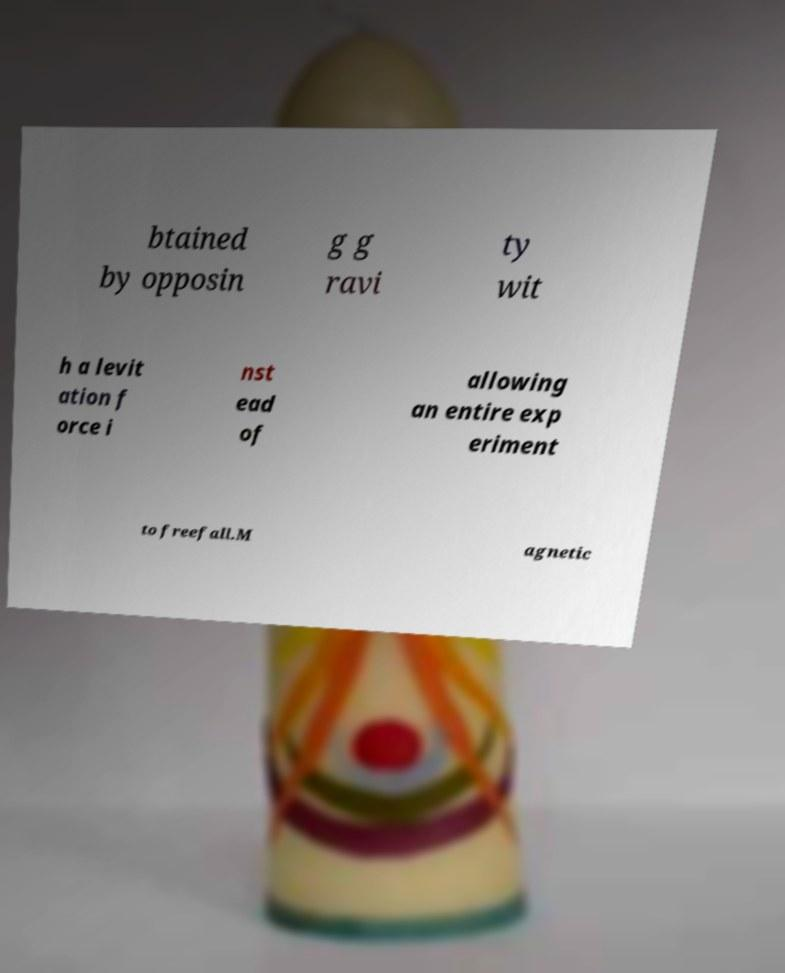For documentation purposes, I need the text within this image transcribed. Could you provide that? btained by opposin g g ravi ty wit h a levit ation f orce i nst ead of allowing an entire exp eriment to freefall.M agnetic 